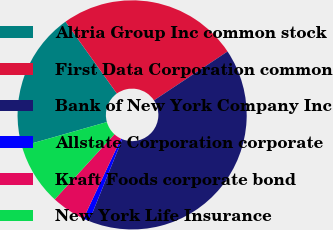Convert chart to OTSL. <chart><loc_0><loc_0><loc_500><loc_500><pie_chart><fcel>Altria Group Inc common stock<fcel>First Data Corporation common<fcel>Bank of New York Company Inc<fcel>Allstate Corporation corporate<fcel>Kraft Foods corporate bond<fcel>New York Life Insurance<nl><fcel>19.54%<fcel>25.54%<fcel>40.46%<fcel>0.86%<fcel>4.82%<fcel>8.78%<nl></chart> 